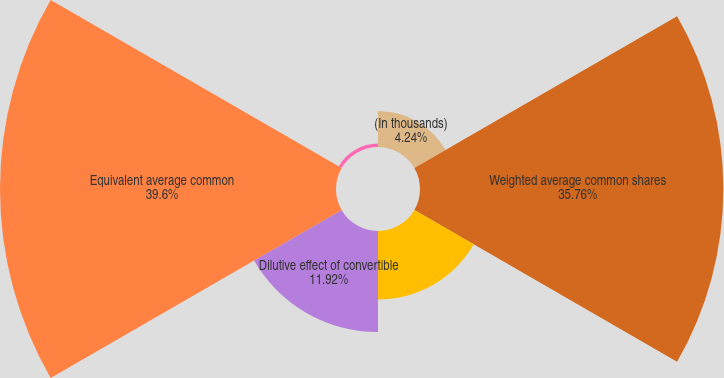<chart> <loc_0><loc_0><loc_500><loc_500><pie_chart><fcel>(In thousands)<fcel>Weighted average common shares<fcel>Dilutive effect of stock<fcel>Dilutive effect of convertible<fcel>Equivalent average common<fcel>Antidilutive stock options<nl><fcel>4.24%<fcel>35.76%<fcel>8.08%<fcel>11.92%<fcel>39.61%<fcel>0.4%<nl></chart> 